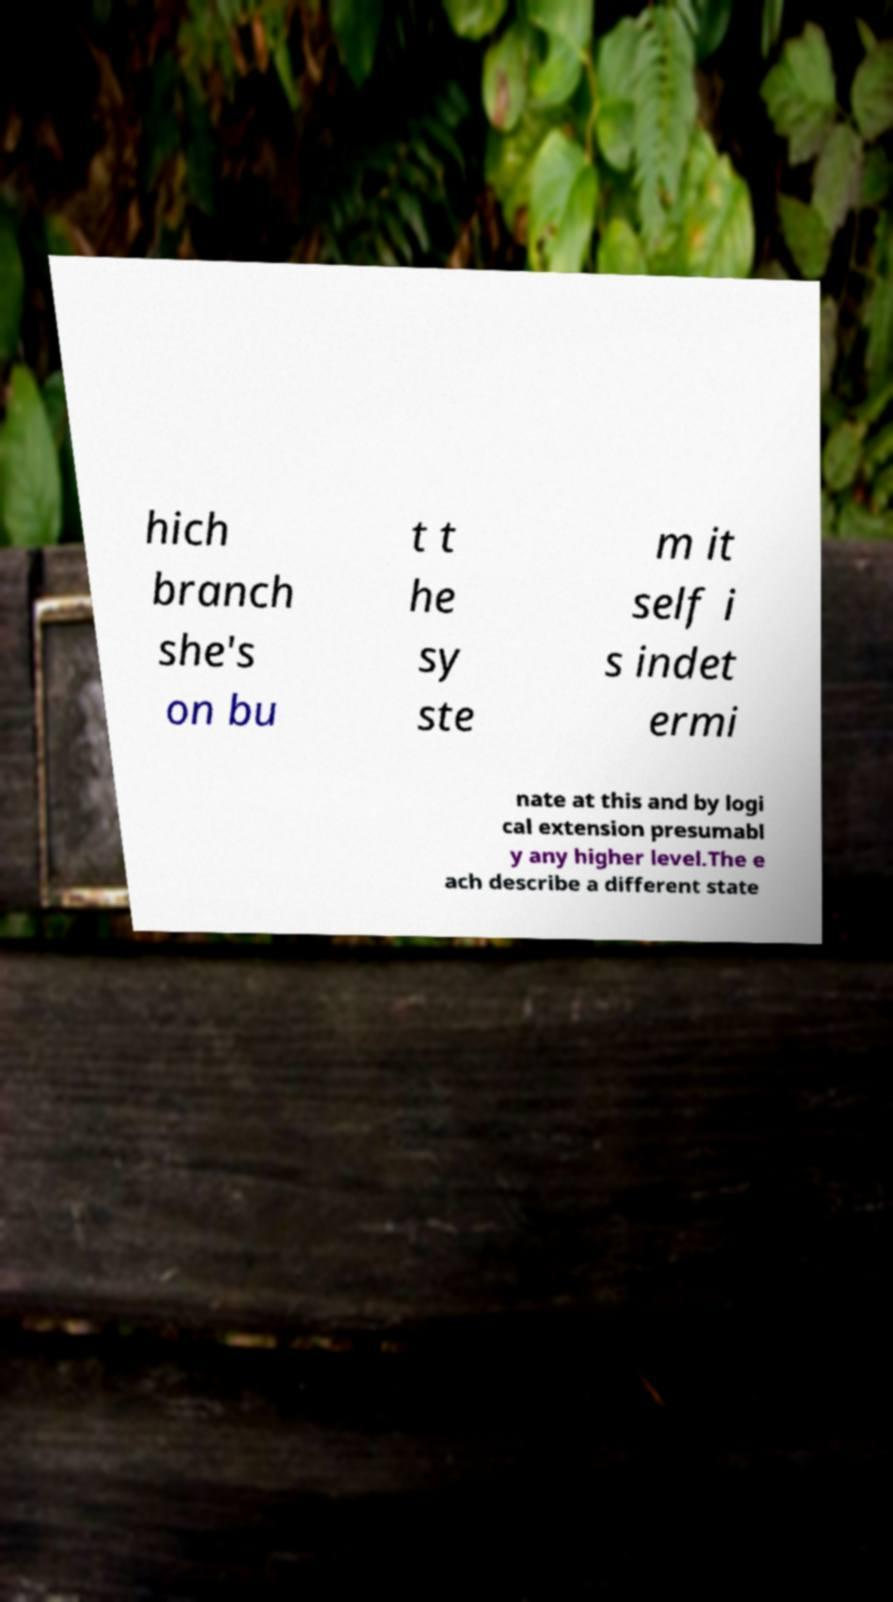For documentation purposes, I need the text within this image transcribed. Could you provide that? hich branch she's on bu t t he sy ste m it self i s indet ermi nate at this and by logi cal extension presumabl y any higher level.The e ach describe a different state 